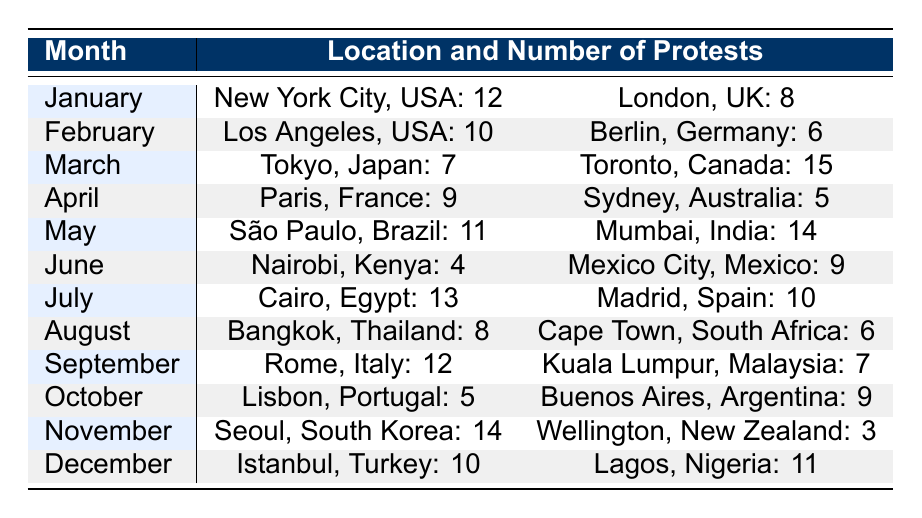What location had the highest number of protests in March? In March, the table shows that Toronto, Canada had 15 protests, which is higher than all other locations listed for that month (Tokyo had 7 protests).
Answer: Toronto, Canada How many protests occurred in London, UK? The table indicates that there were 8 protests in London, UK in January.
Answer: 8 Which month had the least number of protests in Nairobi, Kenya? The table shows that Nairobi, Kenya had the least number of protests in June, with a total of 4 protests compared to other months' totals.
Answer: June What is the total number of protests in May across both locations? The table lists 11 protests in São Paulo, Brazil and 14 in Mumbai, India for May. Summing these gives 11 + 14 = 25 protests.
Answer: 25 Is it true that Rome, Italy had more protests than Kuala Lumpur, Malaysia in September? Looking at the table, Rome had 12 protests while Kuala Lumpur had 7 protests in September, confirming the statement is true.
Answer: Yes What is the difference in the number of protests between July and August in Cairo, Egypt, and Bangkok, Thailand? In July, Cairo had 13 protests, and in August, Bangkok had 8 protests. The difference is 13 - 8 = 5.
Answer: 5 Which location had a higher number of protests: Istanbul, Turkey in December or Paris, France in April? The table shows Istanbul had 10 protests and Paris had 9 protests. Since 10 > 9, Istanbul had more protests than Paris.
Answer: Istanbul, Turkey What was the average number of protests in the month of February across the listed locations? For February, Los Angeles had 10 protests and Berlin had 6. Their average is (10 + 6) / 2 = 8.
Answer: 8 Which location had exactly 11 protests, and in which month did it occur? The table indicates that Lagos, Nigeria had 11 protests in December.
Answer: Lagos, Nigeria, December 